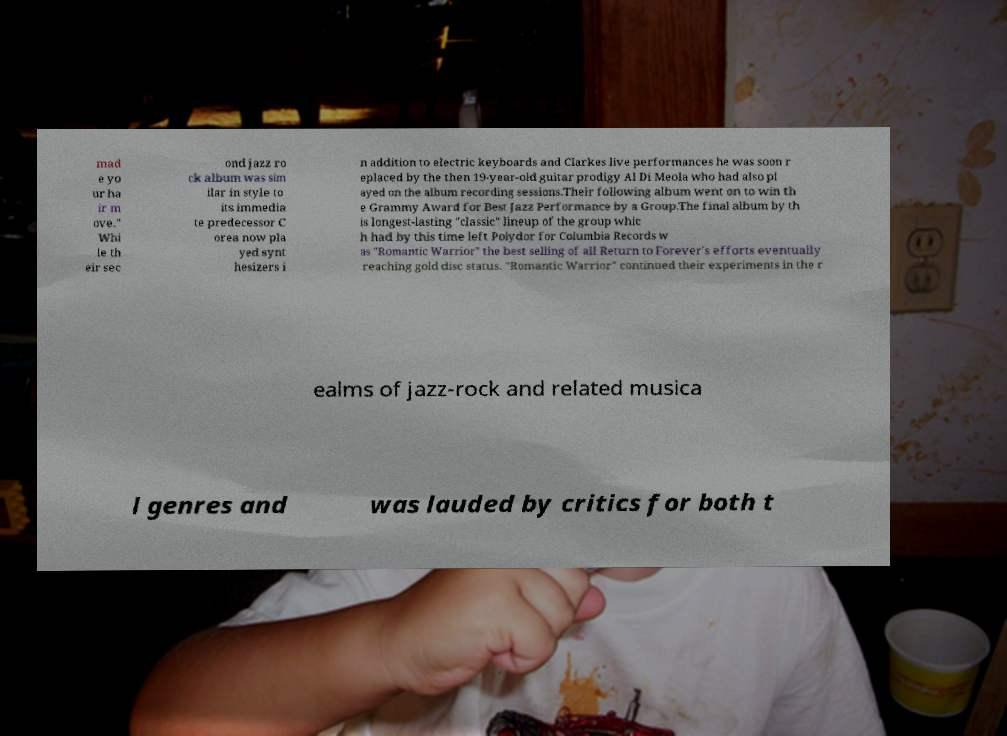What messages or text are displayed in this image? I need them in a readable, typed format. mad e yo ur ha ir m ove." Whi le th eir sec ond jazz ro ck album was sim ilar in style to its immedia te predecessor C orea now pla yed synt hesizers i n addition to electric keyboards and Clarkes live performances he was soon r eplaced by the then 19-year-old guitar prodigy Al Di Meola who had also pl ayed on the album recording sessions.Their following album went on to win th e Grammy Award for Best Jazz Performance by a Group.The final album by th is longest-lasting "classic" lineup of the group whic h had by this time left Polydor for Columbia Records w as "Romantic Warrior" the best selling of all Return to Forever's efforts eventually reaching gold disc status. "Romantic Warrior" continued their experiments in the r ealms of jazz-rock and related musica l genres and was lauded by critics for both t 